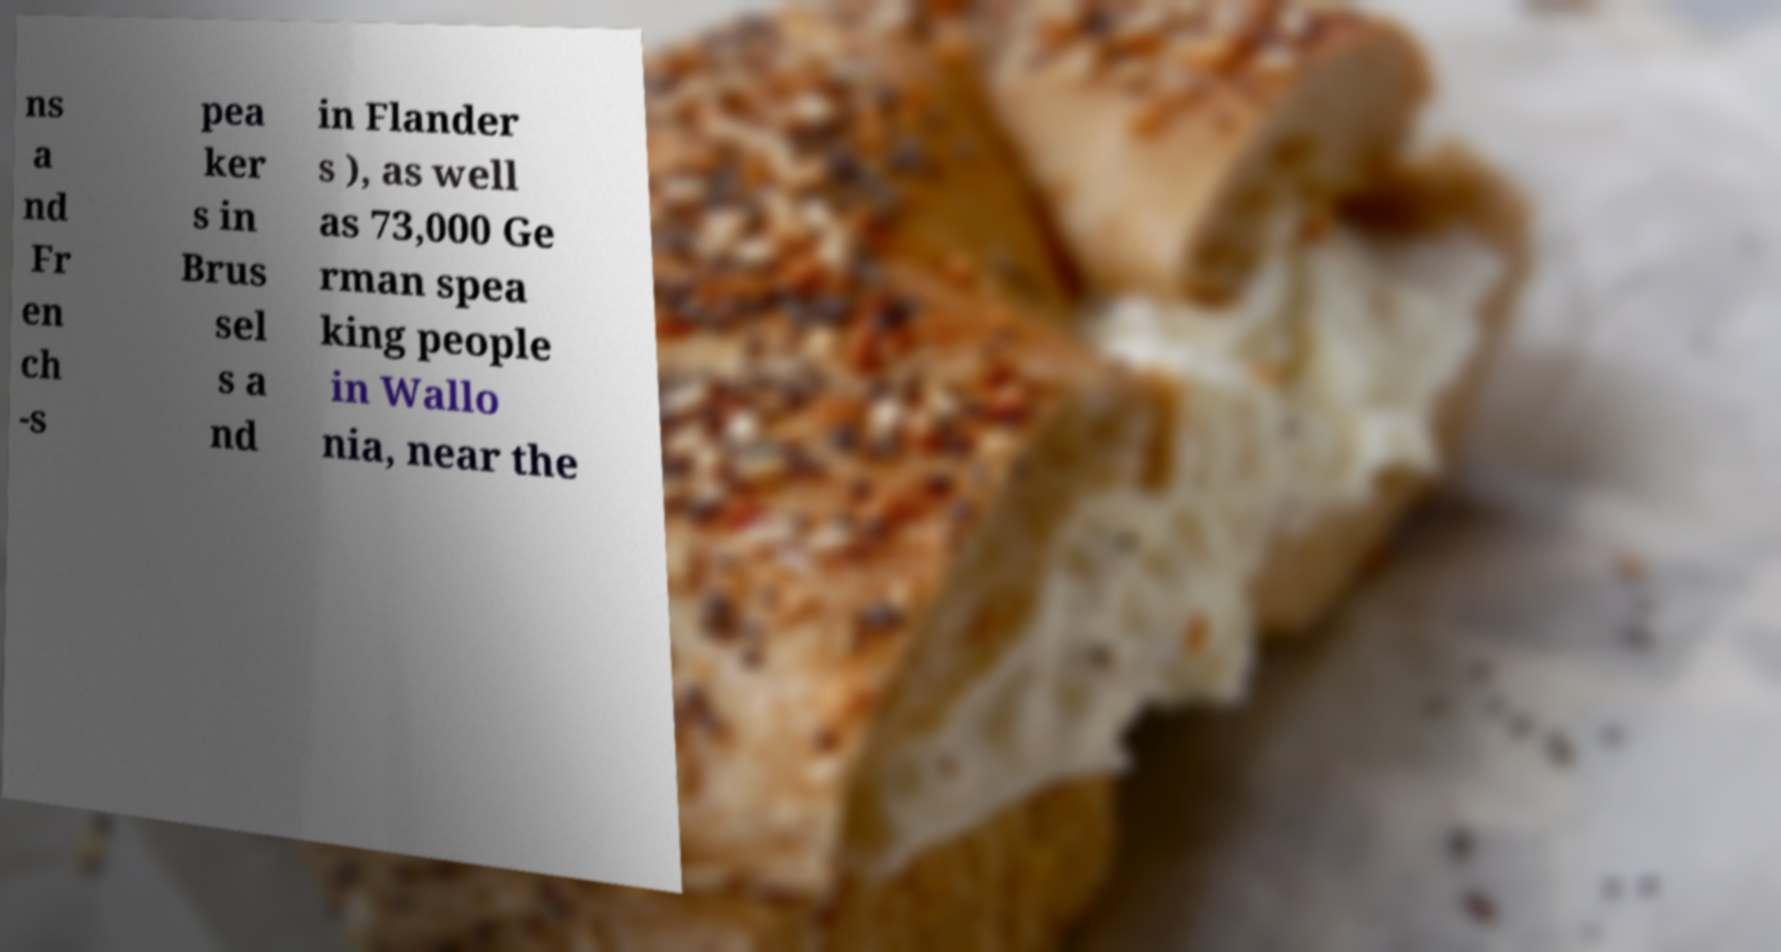Could you assist in decoding the text presented in this image and type it out clearly? ns a nd Fr en ch -s pea ker s in Brus sel s a nd in Flander s ), as well as 73,000 Ge rman spea king people in Wallo nia, near the 